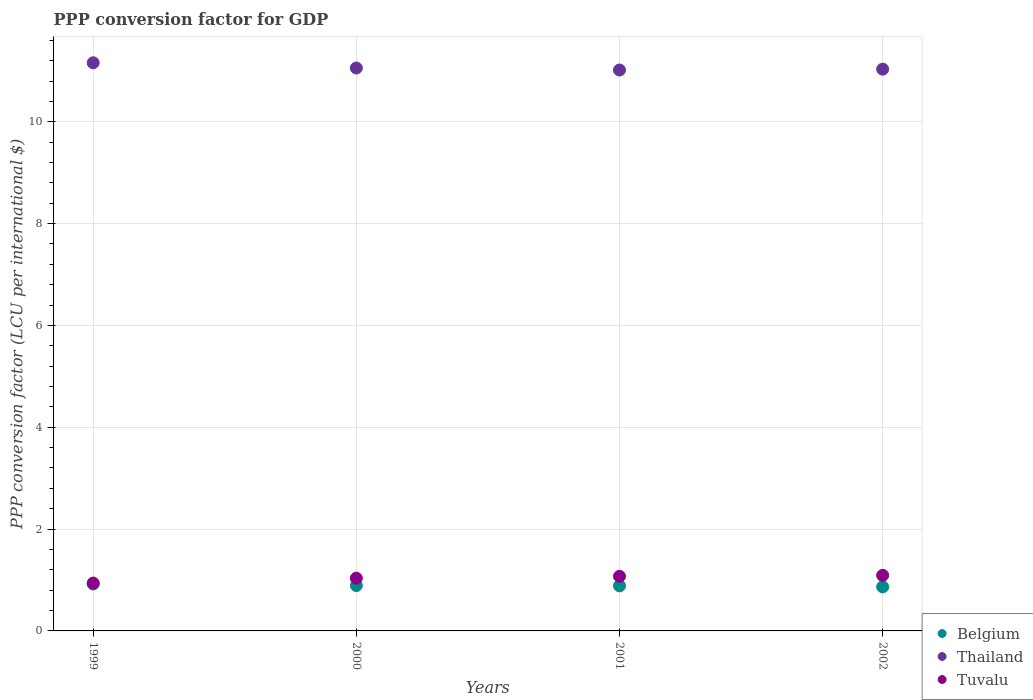What is the PPP conversion factor for GDP in Tuvalu in 1999?
Your response must be concise. 0.94. Across all years, what is the maximum PPP conversion factor for GDP in Tuvalu?
Ensure brevity in your answer.  1.09. Across all years, what is the minimum PPP conversion factor for GDP in Belgium?
Keep it short and to the point. 0.87. What is the total PPP conversion factor for GDP in Belgium in the graph?
Your response must be concise. 3.56. What is the difference between the PPP conversion factor for GDP in Tuvalu in 2000 and that in 2001?
Provide a succinct answer. -0.04. What is the difference between the PPP conversion factor for GDP in Thailand in 2002 and the PPP conversion factor for GDP in Tuvalu in 1999?
Your answer should be very brief. 10.09. What is the average PPP conversion factor for GDP in Tuvalu per year?
Provide a succinct answer. 1.03. In the year 1999, what is the difference between the PPP conversion factor for GDP in Thailand and PPP conversion factor for GDP in Tuvalu?
Keep it short and to the point. 10.22. What is the ratio of the PPP conversion factor for GDP in Thailand in 2000 to that in 2002?
Offer a terse response. 1. Is the PPP conversion factor for GDP in Belgium in 1999 less than that in 2002?
Your response must be concise. No. What is the difference between the highest and the second highest PPP conversion factor for GDP in Thailand?
Your answer should be very brief. 0.1. What is the difference between the highest and the lowest PPP conversion factor for GDP in Tuvalu?
Your response must be concise. 0.15. Does the PPP conversion factor for GDP in Belgium monotonically increase over the years?
Offer a very short reply. No. Is the PPP conversion factor for GDP in Tuvalu strictly greater than the PPP conversion factor for GDP in Belgium over the years?
Ensure brevity in your answer.  Yes. Is the PPP conversion factor for GDP in Tuvalu strictly less than the PPP conversion factor for GDP in Thailand over the years?
Give a very brief answer. Yes. How many years are there in the graph?
Your response must be concise. 4. What is the difference between two consecutive major ticks on the Y-axis?
Make the answer very short. 2. Does the graph contain grids?
Ensure brevity in your answer.  Yes. Where does the legend appear in the graph?
Provide a succinct answer. Bottom right. How are the legend labels stacked?
Offer a terse response. Vertical. What is the title of the graph?
Your answer should be compact. PPP conversion factor for GDP. What is the label or title of the X-axis?
Offer a terse response. Years. What is the label or title of the Y-axis?
Give a very brief answer. PPP conversion factor (LCU per international $). What is the PPP conversion factor (LCU per international $) of Belgium in 1999?
Give a very brief answer. 0.92. What is the PPP conversion factor (LCU per international $) of Thailand in 1999?
Provide a succinct answer. 11.16. What is the PPP conversion factor (LCU per international $) of Tuvalu in 1999?
Provide a succinct answer. 0.94. What is the PPP conversion factor (LCU per international $) of Belgium in 2000?
Keep it short and to the point. 0.89. What is the PPP conversion factor (LCU per international $) of Thailand in 2000?
Provide a succinct answer. 11.06. What is the PPP conversion factor (LCU per international $) of Tuvalu in 2000?
Provide a succinct answer. 1.04. What is the PPP conversion factor (LCU per international $) in Belgium in 2001?
Offer a very short reply. 0.89. What is the PPP conversion factor (LCU per international $) in Thailand in 2001?
Keep it short and to the point. 11.02. What is the PPP conversion factor (LCU per international $) in Tuvalu in 2001?
Provide a succinct answer. 1.07. What is the PPP conversion factor (LCU per international $) in Belgium in 2002?
Your response must be concise. 0.87. What is the PPP conversion factor (LCU per international $) of Thailand in 2002?
Give a very brief answer. 11.03. What is the PPP conversion factor (LCU per international $) of Tuvalu in 2002?
Provide a succinct answer. 1.09. Across all years, what is the maximum PPP conversion factor (LCU per international $) of Belgium?
Offer a terse response. 0.92. Across all years, what is the maximum PPP conversion factor (LCU per international $) of Thailand?
Make the answer very short. 11.16. Across all years, what is the maximum PPP conversion factor (LCU per international $) in Tuvalu?
Make the answer very short. 1.09. Across all years, what is the minimum PPP conversion factor (LCU per international $) of Belgium?
Make the answer very short. 0.87. Across all years, what is the minimum PPP conversion factor (LCU per international $) of Thailand?
Offer a very short reply. 11.02. Across all years, what is the minimum PPP conversion factor (LCU per international $) in Tuvalu?
Your answer should be very brief. 0.94. What is the total PPP conversion factor (LCU per international $) of Belgium in the graph?
Give a very brief answer. 3.56. What is the total PPP conversion factor (LCU per international $) in Thailand in the graph?
Offer a very short reply. 44.26. What is the total PPP conversion factor (LCU per international $) in Tuvalu in the graph?
Your answer should be very brief. 4.14. What is the difference between the PPP conversion factor (LCU per international $) of Belgium in 1999 and that in 2000?
Make the answer very short. 0.03. What is the difference between the PPP conversion factor (LCU per international $) in Thailand in 1999 and that in 2000?
Provide a succinct answer. 0.1. What is the difference between the PPP conversion factor (LCU per international $) in Tuvalu in 1999 and that in 2000?
Your answer should be very brief. -0.1. What is the difference between the PPP conversion factor (LCU per international $) of Belgium in 1999 and that in 2001?
Provide a short and direct response. 0.04. What is the difference between the PPP conversion factor (LCU per international $) of Thailand in 1999 and that in 2001?
Give a very brief answer. 0.14. What is the difference between the PPP conversion factor (LCU per international $) of Tuvalu in 1999 and that in 2001?
Your answer should be compact. -0.13. What is the difference between the PPP conversion factor (LCU per international $) of Belgium in 1999 and that in 2002?
Provide a succinct answer. 0.06. What is the difference between the PPP conversion factor (LCU per international $) of Thailand in 1999 and that in 2002?
Make the answer very short. 0.13. What is the difference between the PPP conversion factor (LCU per international $) in Tuvalu in 1999 and that in 2002?
Your answer should be compact. -0.15. What is the difference between the PPP conversion factor (LCU per international $) in Belgium in 2000 and that in 2001?
Offer a very short reply. 0.01. What is the difference between the PPP conversion factor (LCU per international $) in Thailand in 2000 and that in 2001?
Offer a terse response. 0.04. What is the difference between the PPP conversion factor (LCU per international $) of Tuvalu in 2000 and that in 2001?
Ensure brevity in your answer.  -0.04. What is the difference between the PPP conversion factor (LCU per international $) in Belgium in 2000 and that in 2002?
Your response must be concise. 0.03. What is the difference between the PPP conversion factor (LCU per international $) of Thailand in 2000 and that in 2002?
Your answer should be very brief. 0.02. What is the difference between the PPP conversion factor (LCU per international $) in Tuvalu in 2000 and that in 2002?
Offer a very short reply. -0.06. What is the difference between the PPP conversion factor (LCU per international $) of Belgium in 2001 and that in 2002?
Keep it short and to the point. 0.02. What is the difference between the PPP conversion factor (LCU per international $) in Thailand in 2001 and that in 2002?
Your response must be concise. -0.02. What is the difference between the PPP conversion factor (LCU per international $) of Tuvalu in 2001 and that in 2002?
Ensure brevity in your answer.  -0.02. What is the difference between the PPP conversion factor (LCU per international $) of Belgium in 1999 and the PPP conversion factor (LCU per international $) of Thailand in 2000?
Your answer should be very brief. -10.13. What is the difference between the PPP conversion factor (LCU per international $) of Belgium in 1999 and the PPP conversion factor (LCU per international $) of Tuvalu in 2000?
Provide a short and direct response. -0.11. What is the difference between the PPP conversion factor (LCU per international $) in Thailand in 1999 and the PPP conversion factor (LCU per international $) in Tuvalu in 2000?
Offer a terse response. 10.12. What is the difference between the PPP conversion factor (LCU per international $) of Belgium in 1999 and the PPP conversion factor (LCU per international $) of Thailand in 2001?
Keep it short and to the point. -10.1. What is the difference between the PPP conversion factor (LCU per international $) of Belgium in 1999 and the PPP conversion factor (LCU per international $) of Tuvalu in 2001?
Your answer should be very brief. -0.15. What is the difference between the PPP conversion factor (LCU per international $) of Thailand in 1999 and the PPP conversion factor (LCU per international $) of Tuvalu in 2001?
Provide a short and direct response. 10.09. What is the difference between the PPP conversion factor (LCU per international $) of Belgium in 1999 and the PPP conversion factor (LCU per international $) of Thailand in 2002?
Make the answer very short. -10.11. What is the difference between the PPP conversion factor (LCU per international $) in Belgium in 1999 and the PPP conversion factor (LCU per international $) in Tuvalu in 2002?
Your response must be concise. -0.17. What is the difference between the PPP conversion factor (LCU per international $) in Thailand in 1999 and the PPP conversion factor (LCU per international $) in Tuvalu in 2002?
Provide a short and direct response. 10.07. What is the difference between the PPP conversion factor (LCU per international $) of Belgium in 2000 and the PPP conversion factor (LCU per international $) of Thailand in 2001?
Give a very brief answer. -10.13. What is the difference between the PPP conversion factor (LCU per international $) of Belgium in 2000 and the PPP conversion factor (LCU per international $) of Tuvalu in 2001?
Give a very brief answer. -0.18. What is the difference between the PPP conversion factor (LCU per international $) in Thailand in 2000 and the PPP conversion factor (LCU per international $) in Tuvalu in 2001?
Your answer should be very brief. 9.98. What is the difference between the PPP conversion factor (LCU per international $) in Belgium in 2000 and the PPP conversion factor (LCU per international $) in Thailand in 2002?
Provide a succinct answer. -10.14. What is the difference between the PPP conversion factor (LCU per international $) in Belgium in 2000 and the PPP conversion factor (LCU per international $) in Tuvalu in 2002?
Make the answer very short. -0.2. What is the difference between the PPP conversion factor (LCU per international $) in Thailand in 2000 and the PPP conversion factor (LCU per international $) in Tuvalu in 2002?
Your response must be concise. 9.96. What is the difference between the PPP conversion factor (LCU per international $) of Belgium in 2001 and the PPP conversion factor (LCU per international $) of Thailand in 2002?
Give a very brief answer. -10.15. What is the difference between the PPP conversion factor (LCU per international $) in Belgium in 2001 and the PPP conversion factor (LCU per international $) in Tuvalu in 2002?
Provide a succinct answer. -0.21. What is the difference between the PPP conversion factor (LCU per international $) in Thailand in 2001 and the PPP conversion factor (LCU per international $) in Tuvalu in 2002?
Your response must be concise. 9.92. What is the average PPP conversion factor (LCU per international $) in Belgium per year?
Give a very brief answer. 0.89. What is the average PPP conversion factor (LCU per international $) in Thailand per year?
Provide a short and direct response. 11.07. What is the average PPP conversion factor (LCU per international $) in Tuvalu per year?
Make the answer very short. 1.03. In the year 1999, what is the difference between the PPP conversion factor (LCU per international $) of Belgium and PPP conversion factor (LCU per international $) of Thailand?
Provide a short and direct response. -10.24. In the year 1999, what is the difference between the PPP conversion factor (LCU per international $) of Belgium and PPP conversion factor (LCU per international $) of Tuvalu?
Ensure brevity in your answer.  -0.02. In the year 1999, what is the difference between the PPP conversion factor (LCU per international $) of Thailand and PPP conversion factor (LCU per international $) of Tuvalu?
Give a very brief answer. 10.22. In the year 2000, what is the difference between the PPP conversion factor (LCU per international $) in Belgium and PPP conversion factor (LCU per international $) in Thailand?
Ensure brevity in your answer.  -10.17. In the year 2000, what is the difference between the PPP conversion factor (LCU per international $) in Belgium and PPP conversion factor (LCU per international $) in Tuvalu?
Give a very brief answer. -0.15. In the year 2000, what is the difference between the PPP conversion factor (LCU per international $) in Thailand and PPP conversion factor (LCU per international $) in Tuvalu?
Your answer should be compact. 10.02. In the year 2001, what is the difference between the PPP conversion factor (LCU per international $) in Belgium and PPP conversion factor (LCU per international $) in Thailand?
Ensure brevity in your answer.  -10.13. In the year 2001, what is the difference between the PPP conversion factor (LCU per international $) in Belgium and PPP conversion factor (LCU per international $) in Tuvalu?
Your answer should be very brief. -0.19. In the year 2001, what is the difference between the PPP conversion factor (LCU per international $) in Thailand and PPP conversion factor (LCU per international $) in Tuvalu?
Provide a succinct answer. 9.94. In the year 2002, what is the difference between the PPP conversion factor (LCU per international $) in Belgium and PPP conversion factor (LCU per international $) in Thailand?
Your response must be concise. -10.17. In the year 2002, what is the difference between the PPP conversion factor (LCU per international $) of Belgium and PPP conversion factor (LCU per international $) of Tuvalu?
Offer a terse response. -0.23. In the year 2002, what is the difference between the PPP conversion factor (LCU per international $) in Thailand and PPP conversion factor (LCU per international $) in Tuvalu?
Your response must be concise. 9.94. What is the ratio of the PPP conversion factor (LCU per international $) in Belgium in 1999 to that in 2000?
Offer a terse response. 1.03. What is the ratio of the PPP conversion factor (LCU per international $) in Thailand in 1999 to that in 2000?
Give a very brief answer. 1.01. What is the ratio of the PPP conversion factor (LCU per international $) of Tuvalu in 1999 to that in 2000?
Your answer should be compact. 0.91. What is the ratio of the PPP conversion factor (LCU per international $) of Belgium in 1999 to that in 2001?
Provide a short and direct response. 1.04. What is the ratio of the PPP conversion factor (LCU per international $) of Thailand in 1999 to that in 2001?
Give a very brief answer. 1.01. What is the ratio of the PPP conversion factor (LCU per international $) of Tuvalu in 1999 to that in 2001?
Provide a succinct answer. 0.88. What is the ratio of the PPP conversion factor (LCU per international $) of Belgium in 1999 to that in 2002?
Provide a succinct answer. 1.06. What is the ratio of the PPP conversion factor (LCU per international $) in Thailand in 1999 to that in 2002?
Provide a succinct answer. 1.01. What is the ratio of the PPP conversion factor (LCU per international $) in Tuvalu in 1999 to that in 2002?
Offer a terse response. 0.86. What is the ratio of the PPP conversion factor (LCU per international $) in Tuvalu in 2000 to that in 2001?
Ensure brevity in your answer.  0.97. What is the ratio of the PPP conversion factor (LCU per international $) of Belgium in 2000 to that in 2002?
Ensure brevity in your answer.  1.03. What is the ratio of the PPP conversion factor (LCU per international $) of Tuvalu in 2000 to that in 2002?
Your response must be concise. 0.95. What is the ratio of the PPP conversion factor (LCU per international $) of Belgium in 2001 to that in 2002?
Make the answer very short. 1.02. What is the ratio of the PPP conversion factor (LCU per international $) in Tuvalu in 2001 to that in 2002?
Make the answer very short. 0.98. What is the difference between the highest and the second highest PPP conversion factor (LCU per international $) in Belgium?
Your answer should be very brief. 0.03. What is the difference between the highest and the second highest PPP conversion factor (LCU per international $) of Thailand?
Offer a very short reply. 0.1. What is the difference between the highest and the second highest PPP conversion factor (LCU per international $) of Tuvalu?
Offer a very short reply. 0.02. What is the difference between the highest and the lowest PPP conversion factor (LCU per international $) in Belgium?
Offer a terse response. 0.06. What is the difference between the highest and the lowest PPP conversion factor (LCU per international $) in Thailand?
Your answer should be very brief. 0.14. What is the difference between the highest and the lowest PPP conversion factor (LCU per international $) in Tuvalu?
Ensure brevity in your answer.  0.15. 